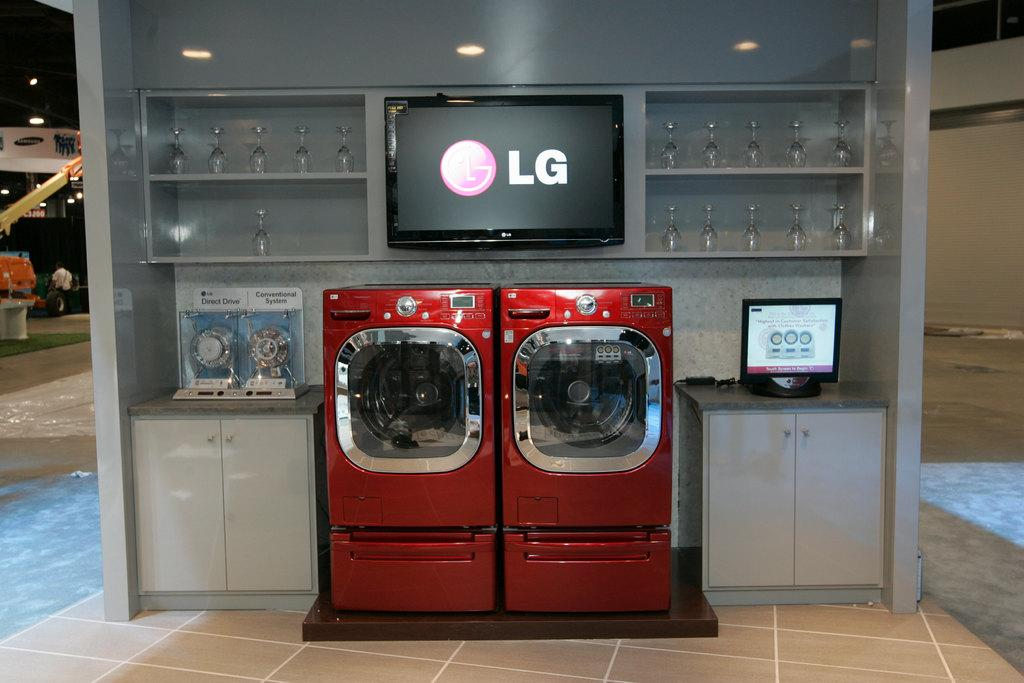Provide a one-sentence caption for the provided image. an LG red washer and dryer display. 